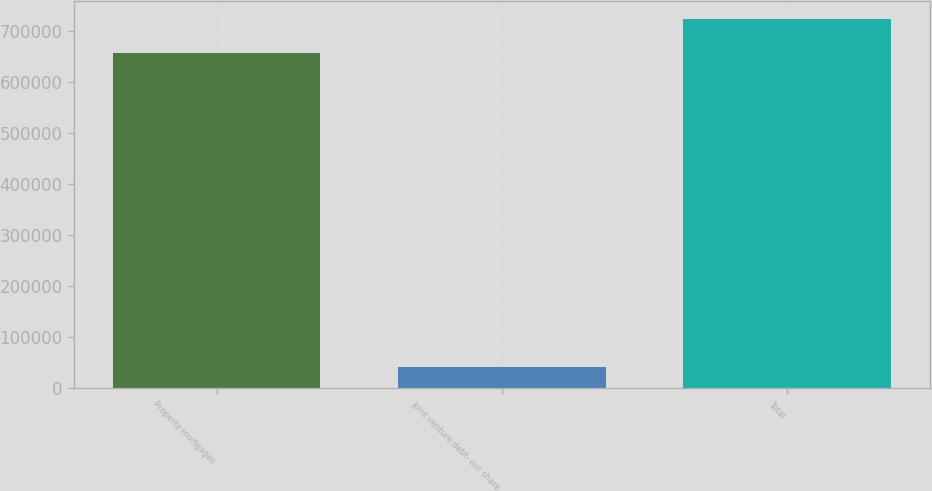Convert chart to OTSL. <chart><loc_0><loc_0><loc_500><loc_500><bar_chart><fcel>Property mortgages<fcel>Joint venture debt- our share<fcel>Total<nl><fcel>656863<fcel>41415<fcel>722549<nl></chart> 